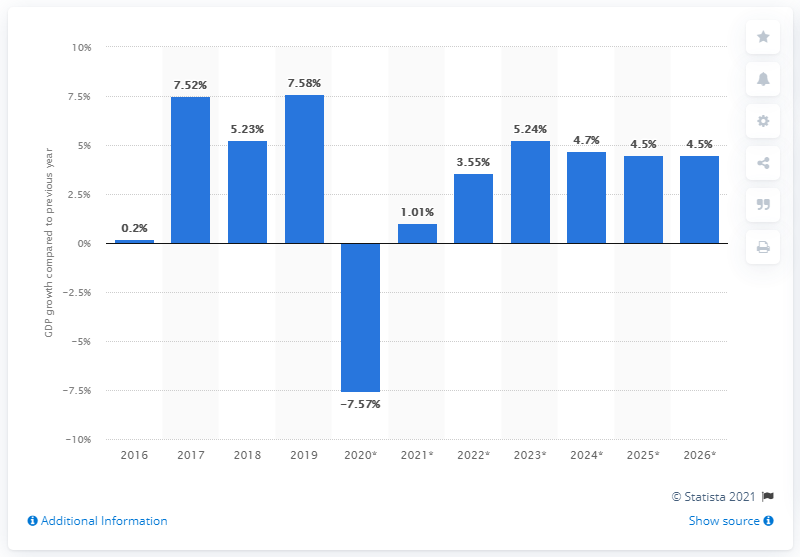Outline some significant characteristics in this image. According to data, Armenia's gross domestic product (GDP) increased by 7.58% in 2019. 